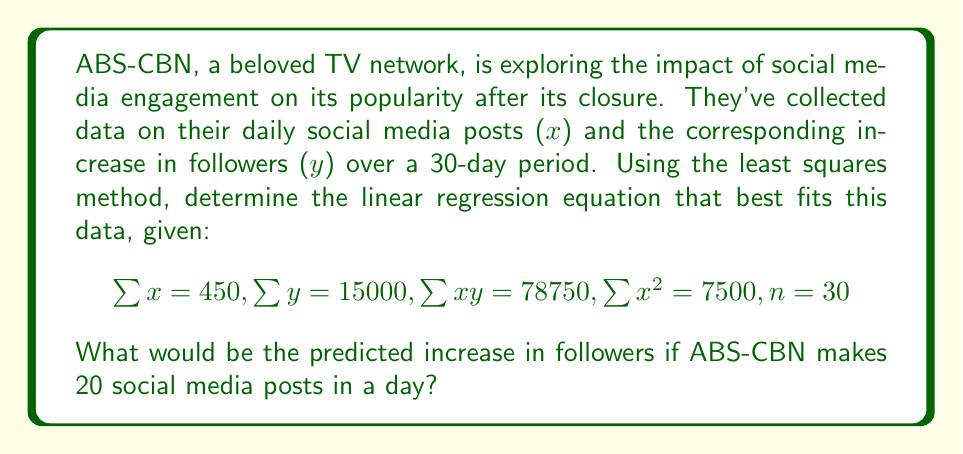Provide a solution to this math problem. To solve this problem, we'll follow these steps:

1) The linear regression equation has the form $y = mx + b$, where $m$ is the slope and $b$ is the y-intercept.

2) For the least squares method, we use these formulas:

   $$m = \frac{n\sum xy - \sum x \sum y}{n\sum x^2 - (\sum x)^2}$$
   
   $$b = \frac{\sum y - m\sum x}{n}$$

3) Let's calculate $m$ first:

   $$m = \frac{30(78750) - (450)(15000)}{30(7500) - (450)^2}$$
   $$= \frac{2362500 - 6750000}{225000 - 202500}$$
   $$= \frac{-4387500}{22500} = -195$$

4) Now let's calculate $b$:

   $$b = \frac{15000 - (-195)(450)}{30}$$
   $$= \frac{15000 + 87750}{30}$$
   $$= \frac{102750}{30} = 3425$$

5) Therefore, our linear regression equation is:

   $$y = -195x + 3425$$

6) To predict the increase in followers for 20 posts, we substitute $x = 20$:

   $$y = -195(20) + 3425 = -3900 + 3425 = -475$$
Answer: $-475$ followers 